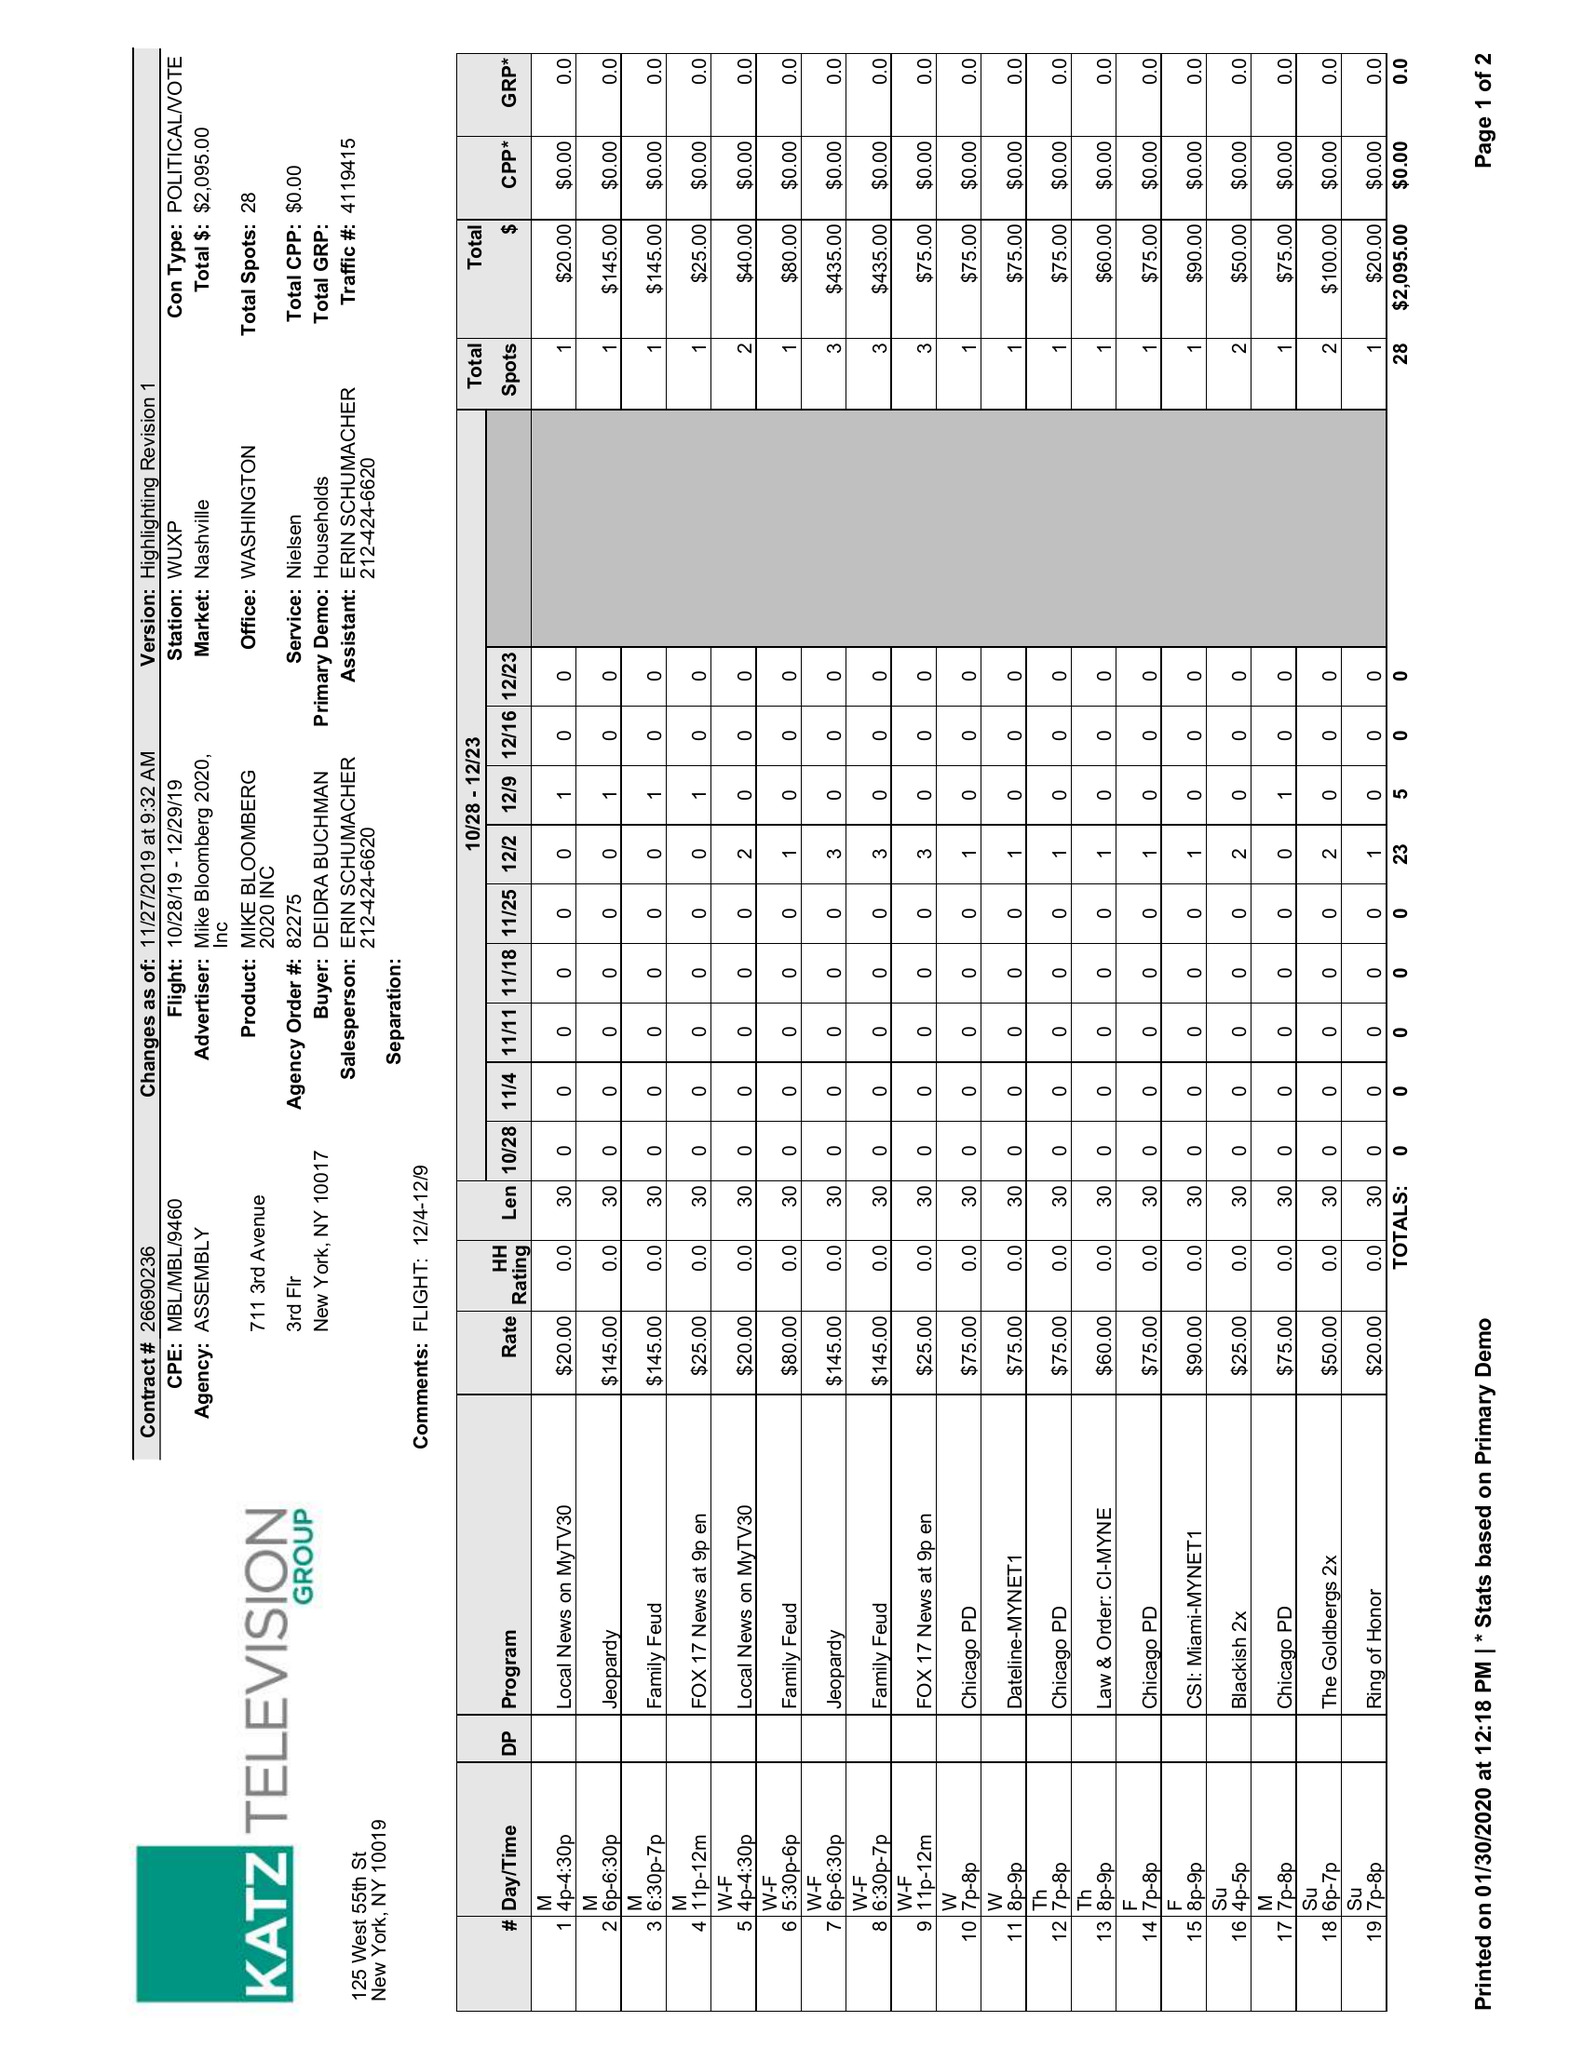What is the value for the flight_to?
Answer the question using a single word or phrase. 12/29/19 